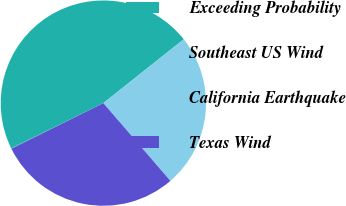<chart> <loc_0><loc_0><loc_500><loc_500><pie_chart><fcel>Exceeding Probability<fcel>Southeast US Wind<fcel>California Earthquake<fcel>Texas Wind<nl><fcel>0.08%<fcel>46.57%<fcel>24.35%<fcel>28.99%<nl></chart> 